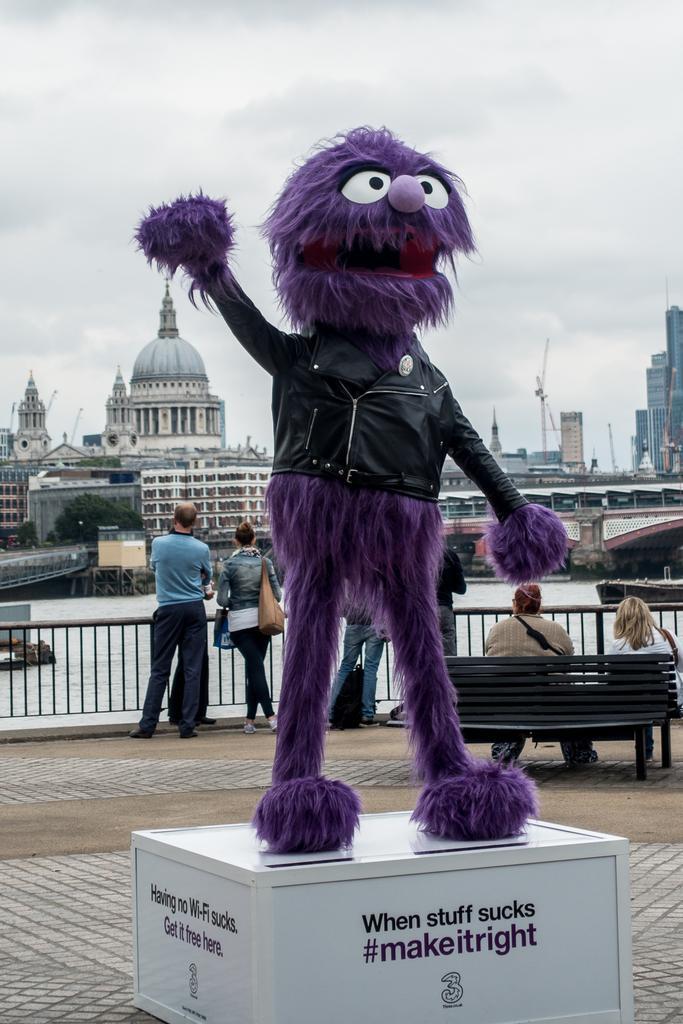Describe this image in one or two sentences. There is a doll placed on a box. There are people and we can see benches, fence and boat above the water. In the background we can see trees, buildings and sky. 